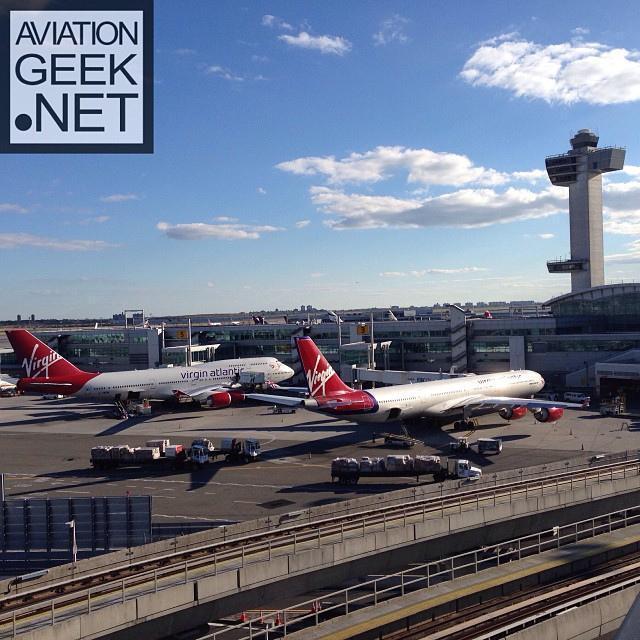How many planes?
Give a very brief answer. 2. How many airplanes are there?
Give a very brief answer. 2. How many trucks are visible?
Give a very brief answer. 2. How many cows are there?
Give a very brief answer. 0. 